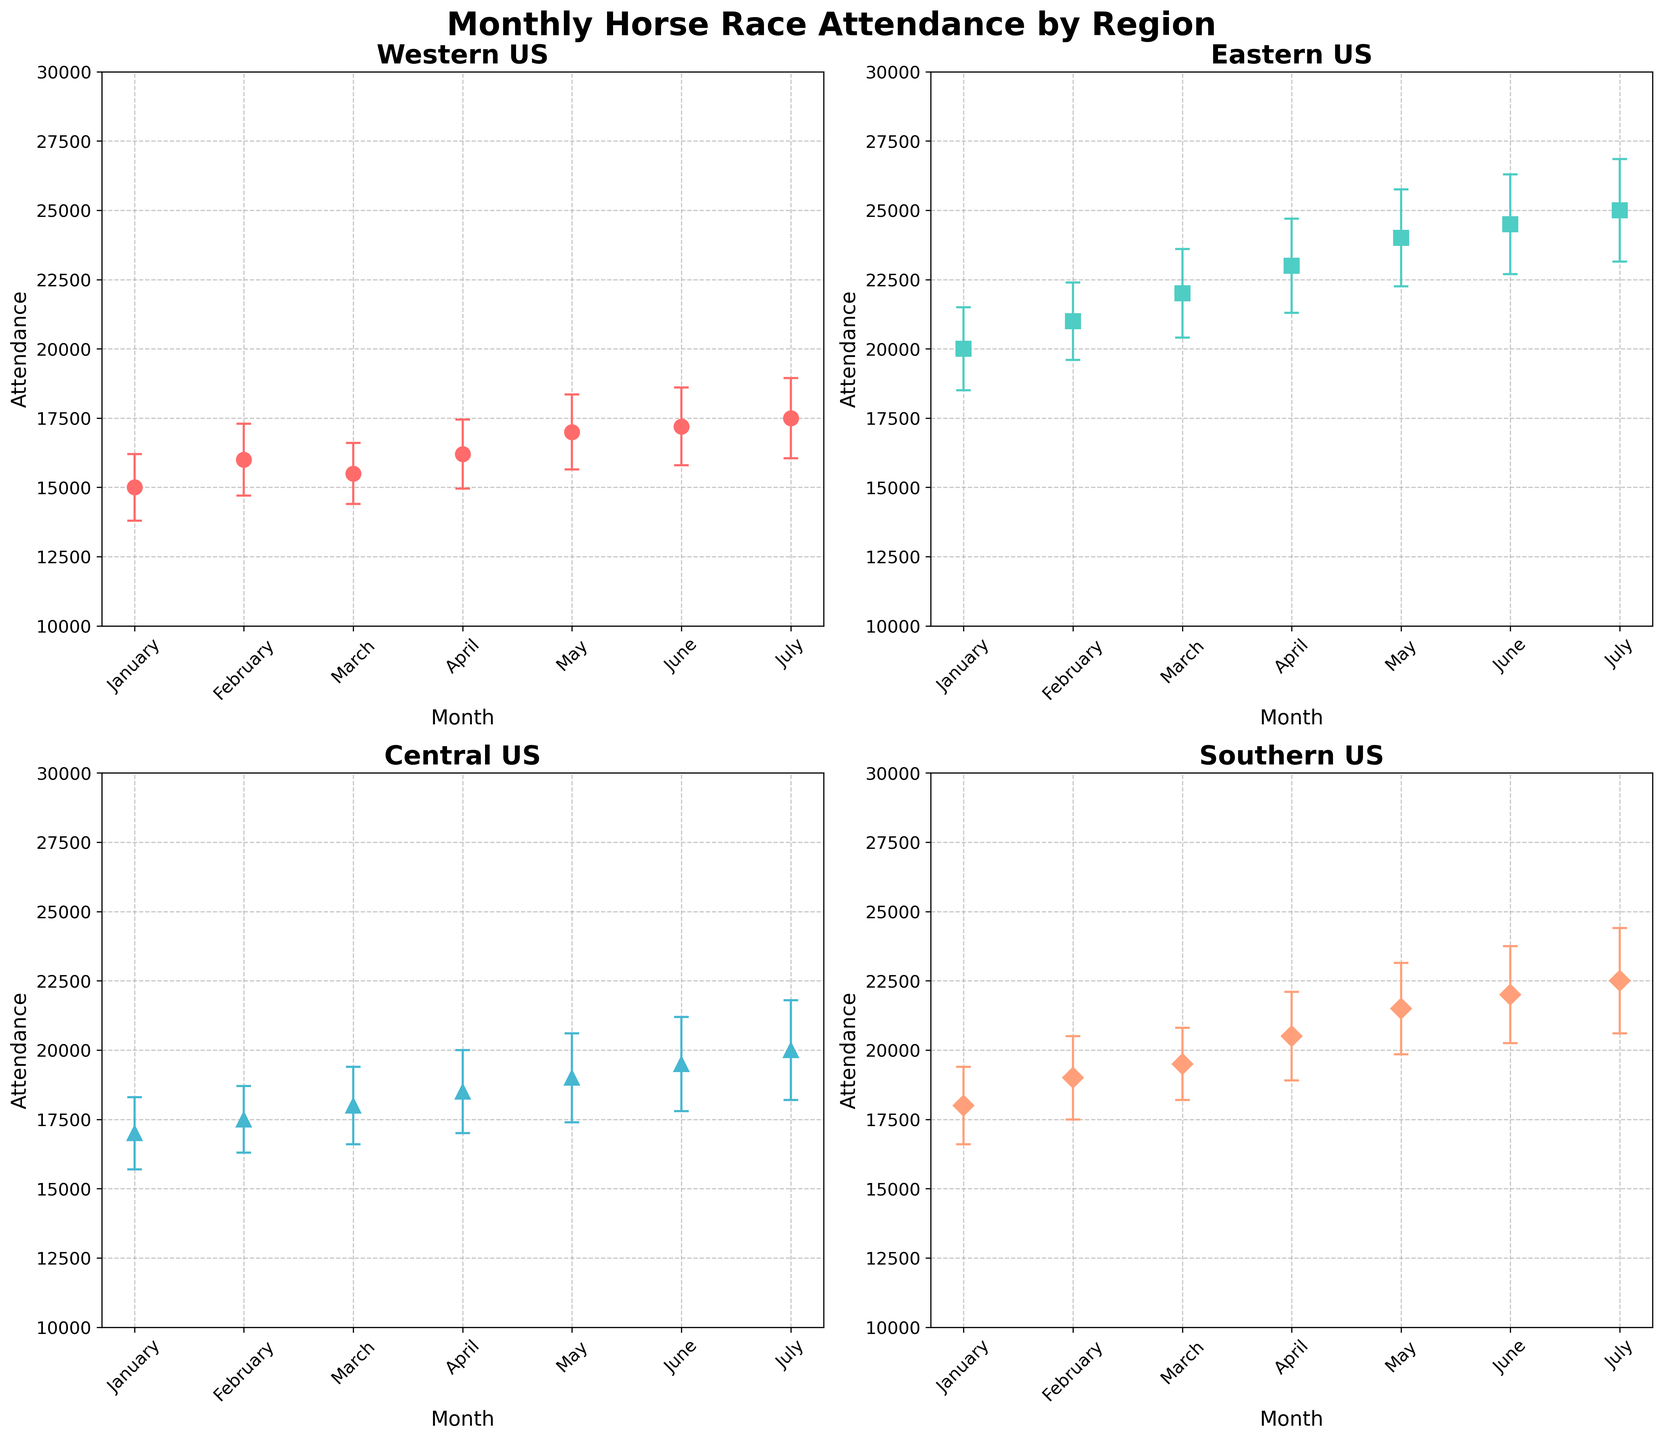What is the title of the figure? The title of the figure is displayed at the top of the illustration. It reads "Monthly Horse Race Attendance by Region," which summarizes the primary content of the visual information.
Answer: Monthly Horse Race Attendance by Region In which month did the Western US see the highest attendance? Focusing on the subplot for the Western US, the highest attendance can be seen at the data point for July with an attendance value of 17,500.
Answer: July Which region had the smallest error margin in July? By examining the subplots for July, including the error bars, the Central US has the smallest error margin, with an error margin of 1,800 compared to the other regions.
Answer: Central US What is the difference in attendance between the Southern US and Eastern US in March? In March, the attendance in the Southern US is 19,500, and in the Eastern US it is 22,000. Subtracting the two values, the difference is 22,000 - 19,500 = 2,500.
Answer: 2,500 Did the Central US show a consistent increase in attendance from January to July? Checking each month's data points for the Central US from January to July, we see that the attendances are: January (17,000), February (17,500), March (18,000), April (18,500), May (19,000), June (19,500), and July (20,000). Attendance consistently increases each month.
Answer: Yes Which month shows the highest overall average attendance across all regions? To find the overall average attendance for each month, we sum the attendance values for the four regions for every month and then divide by 4. By comparing these averages, the highest average is in July: (17,500 + 25,000 + 20,000 + 22,500) / 4 = 21,250.
Answer: July How does the error margin for Eastern US in May compare to that in April? The error margin for Eastern US in May is 1,750, whereas in April it is 1,700. Comparatively, the error margin in May is higher by 50.
Answer: May's error margin is higher by 50 Which region saw the highest increase in attendance between January and February? To determine the highest increase, we subtract January data from February data for each region. Western US: 16,000 - 15,000 = 1,000, Eastern US: 21,000 - 20,000 = 1,000, Central US: 17,500 - 17,000 = 500, Southern US: 19,000 - 18,000 = 1,000. All regions where the increase is 1,000, so no single region saw the highest increase.
Answer: All regions except Central US What are the maximum and minimum values of attendance for the Central US across the months? Searching the subplot for Central US, the minimum value occurs in January (17,000) and the maximum value in July (20,000).
Answer: Minimum: 17,000, Maximum: 20,000 